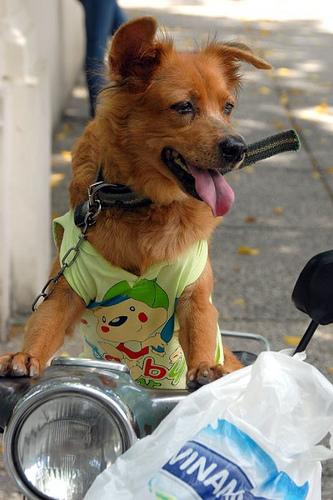What is the dog wearing?
Short answer required. Shirt. What is the dog riding?
Short answer required. Bike. Is the dog tied to a chain?
Short answer required. Yes. 